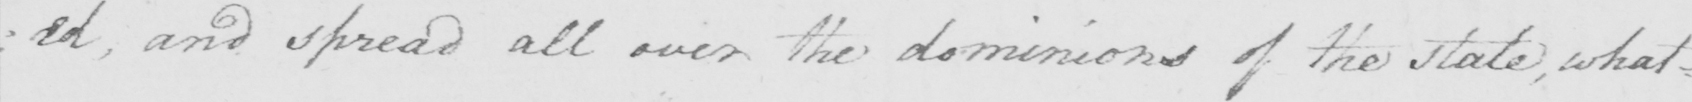What does this handwritten line say? : ed , and spread all over the dominions of the state , what= 